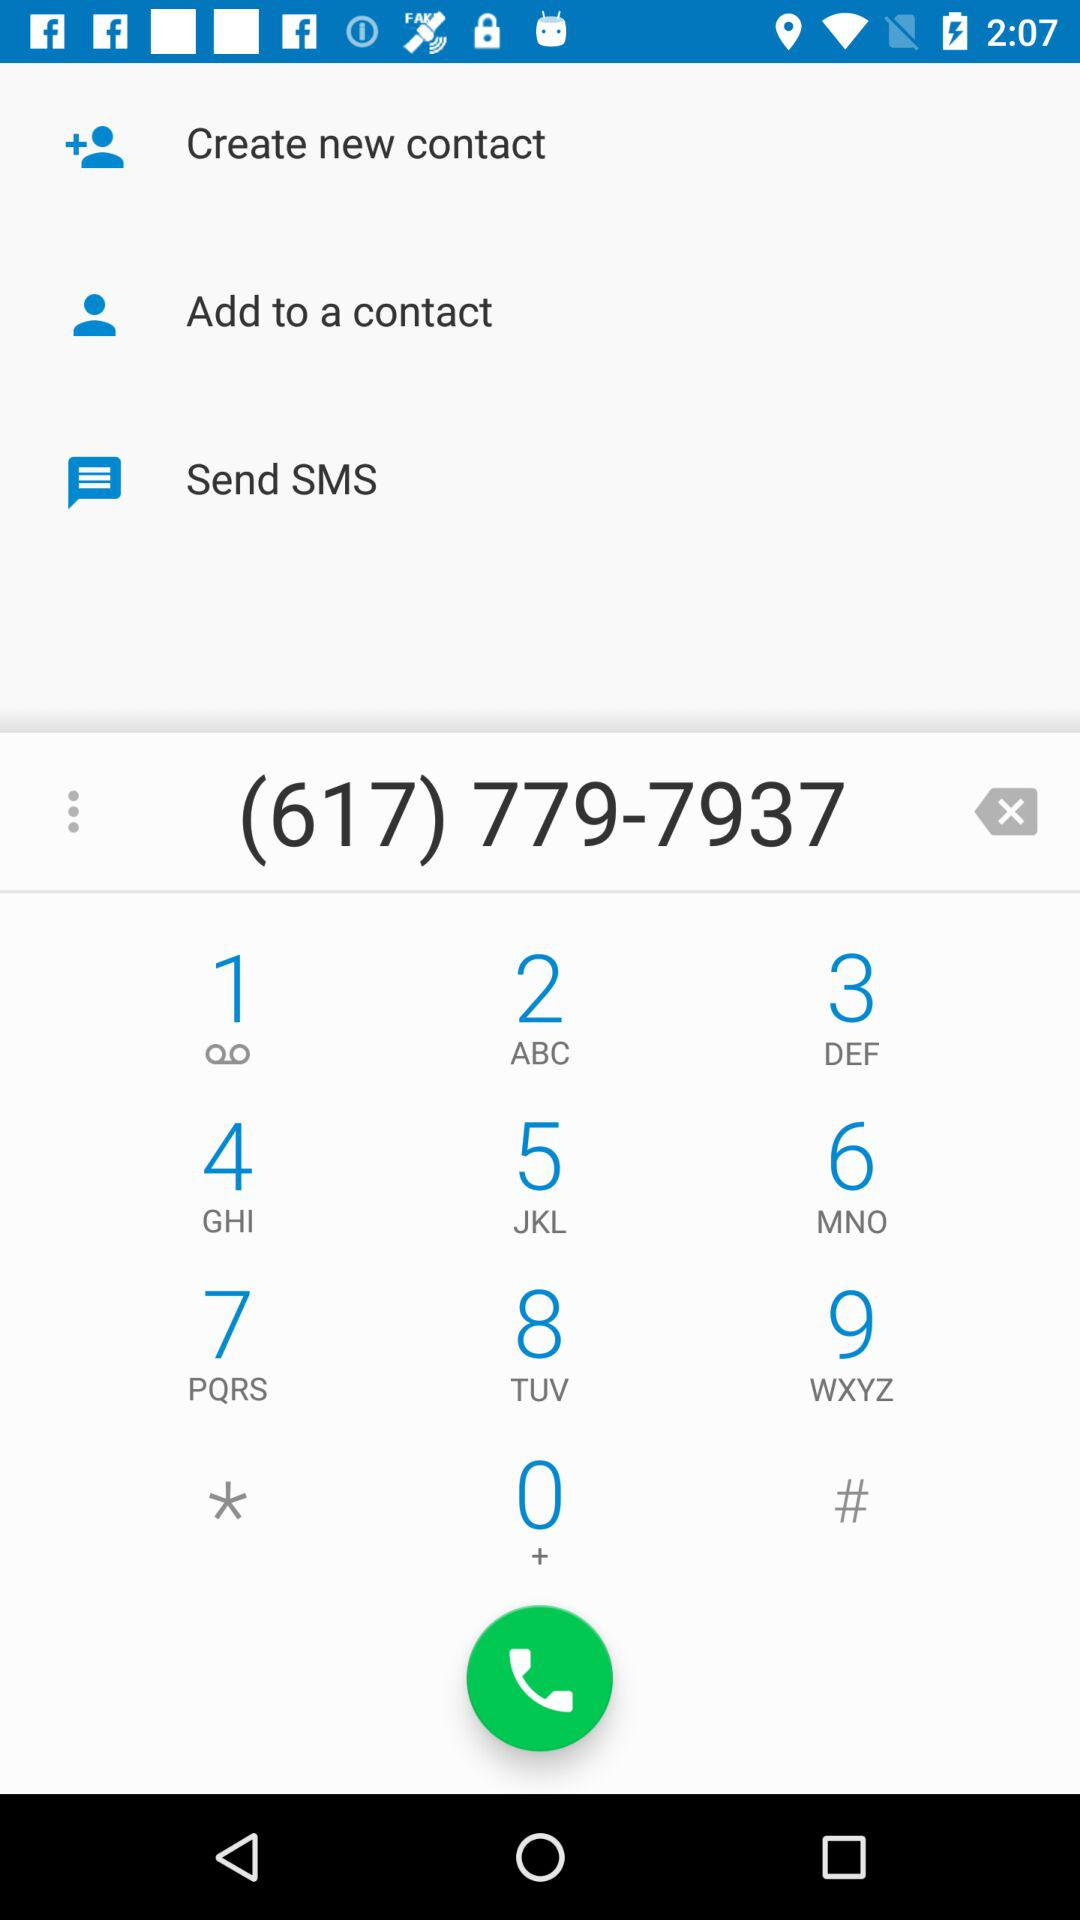What's the typed contact number? The typed contact number is (617) 779-7937. 